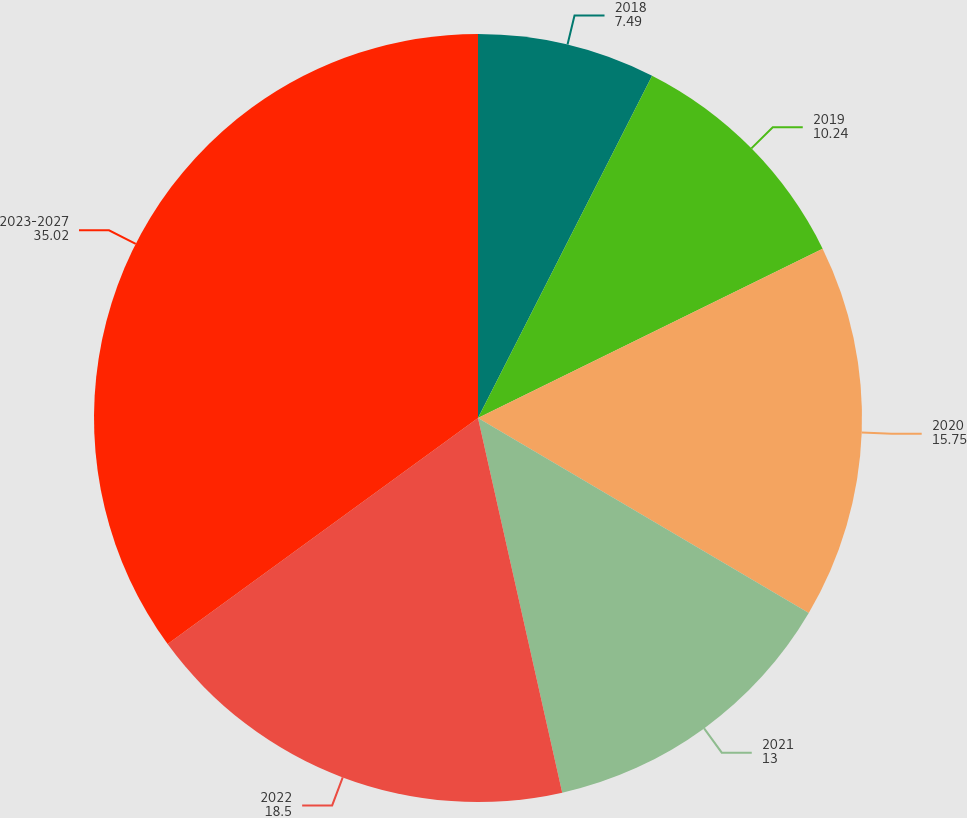Convert chart. <chart><loc_0><loc_0><loc_500><loc_500><pie_chart><fcel>2018<fcel>2019<fcel>2020<fcel>2021<fcel>2022<fcel>2023-2027<nl><fcel>7.49%<fcel>10.24%<fcel>15.75%<fcel>13.0%<fcel>18.5%<fcel>35.02%<nl></chart> 